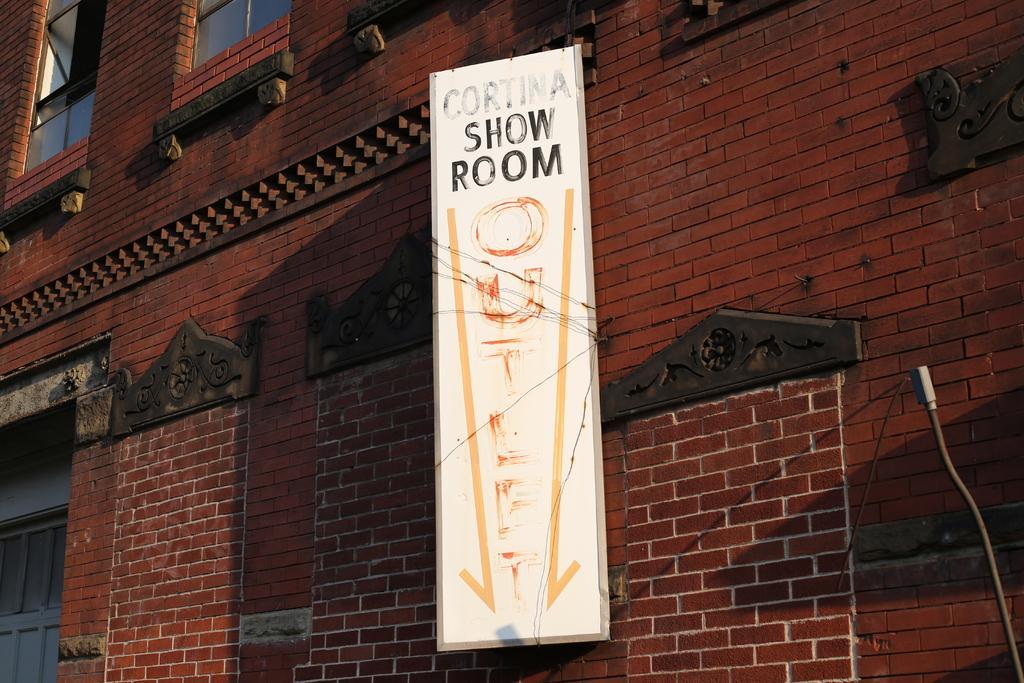How would you summarize this image in a sentence or two? In this image there is a building truncated, there is the wall, there are windows truncated towards the top of the image, there is a board on the building, there is text on the board, there is an object truncated towards the bottom of the image. 